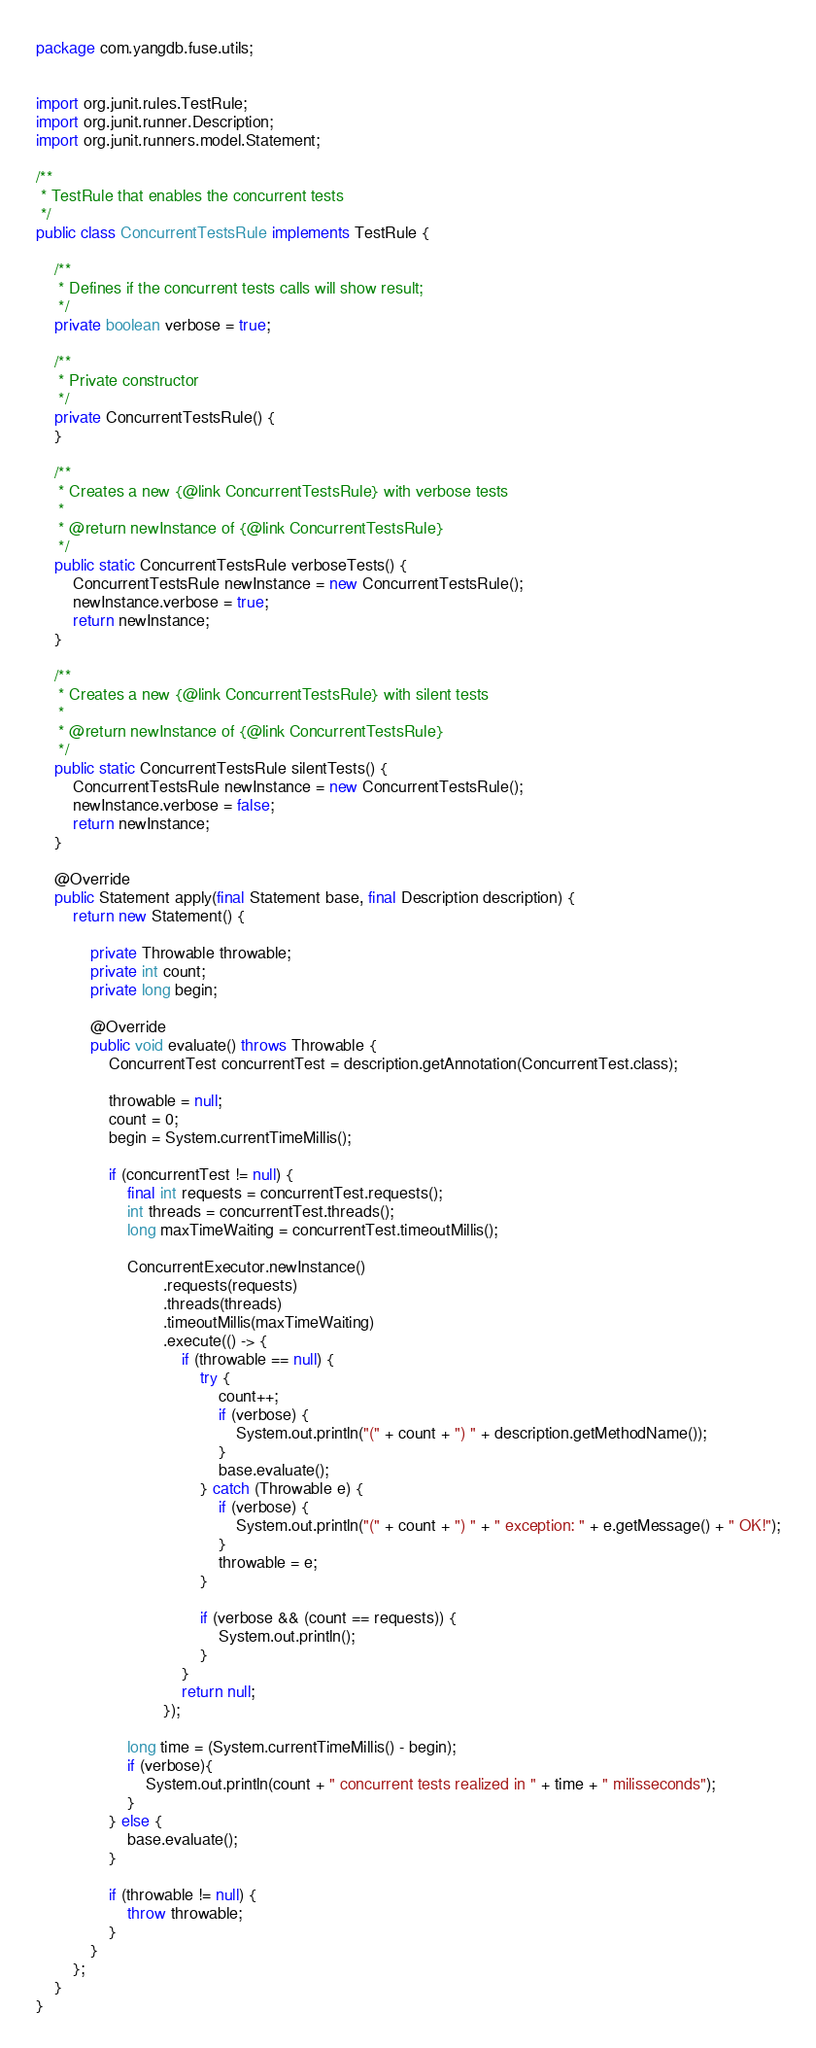Convert code to text. <code><loc_0><loc_0><loc_500><loc_500><_Java_>package com.yangdb.fuse.utils;


import org.junit.rules.TestRule;
import org.junit.runner.Description;
import org.junit.runners.model.Statement;

/**
 * TestRule that enables the concurrent tests
 */
public class ConcurrentTestsRule implements TestRule {

    /**
     * Defines if the concurrent tests calls will show result;
     */
    private boolean verbose = true;

    /**
     * Private constructor
     */
    private ConcurrentTestsRule() {
    }

    /**
     * Creates a new {@link ConcurrentTestsRule} with verbose tests
     *
     * @return newInstance of {@link ConcurrentTestsRule}
     */
    public static ConcurrentTestsRule verboseTests() {
        ConcurrentTestsRule newInstance = new ConcurrentTestsRule();
        newInstance.verbose = true;
        return newInstance;
    }

    /**
     * Creates a new {@link ConcurrentTestsRule} with silent tests
     *
     * @return newInstance of {@link ConcurrentTestsRule}
     */
    public static ConcurrentTestsRule silentTests() {
        ConcurrentTestsRule newInstance = new ConcurrentTestsRule();
        newInstance.verbose = false;
        return newInstance;
    }

    @Override
    public Statement apply(final Statement base, final Description description) {
        return new Statement() {

            private Throwable throwable;
            private int count;
            private long begin;

            @Override
            public void evaluate() throws Throwable {
                ConcurrentTest concurrentTest = description.getAnnotation(ConcurrentTest.class);

                throwable = null;
                count = 0;
                begin = System.currentTimeMillis();

                if (concurrentTest != null) {
                    final int requests = concurrentTest.requests();
                    int threads = concurrentTest.threads();
                    long maxTimeWaiting = concurrentTest.timeoutMillis();

                    ConcurrentExecutor.newInstance()
                            .requests(requests)
                            .threads(threads)
                            .timeoutMillis(maxTimeWaiting)
                            .execute(() -> {
                                if (throwable == null) {
                                    try {
                                        count++;
                                        if (verbose) {
                                            System.out.println("(" + count + ") " + description.getMethodName());
                                        }
                                        base.evaluate();
                                    } catch (Throwable e) {
                                        if (verbose) {
                                            System.out.println("(" + count + ") " + " exception: " + e.getMessage() + " OK!");
                                        }
                                        throwable = e;
                                    }

                                    if (verbose && (count == requests)) {
                                        System.out.println();
                                    }
                                }
                                return null;
                            });

                    long time = (System.currentTimeMillis() - begin);
                    if (verbose){
                        System.out.println(count + " concurrent tests realized in " + time + " milisseconds");
                    }
                } else {
                    base.evaluate();
                }

                if (throwable != null) {
                    throw throwable;
                }
            }
        };
    }
}</code> 